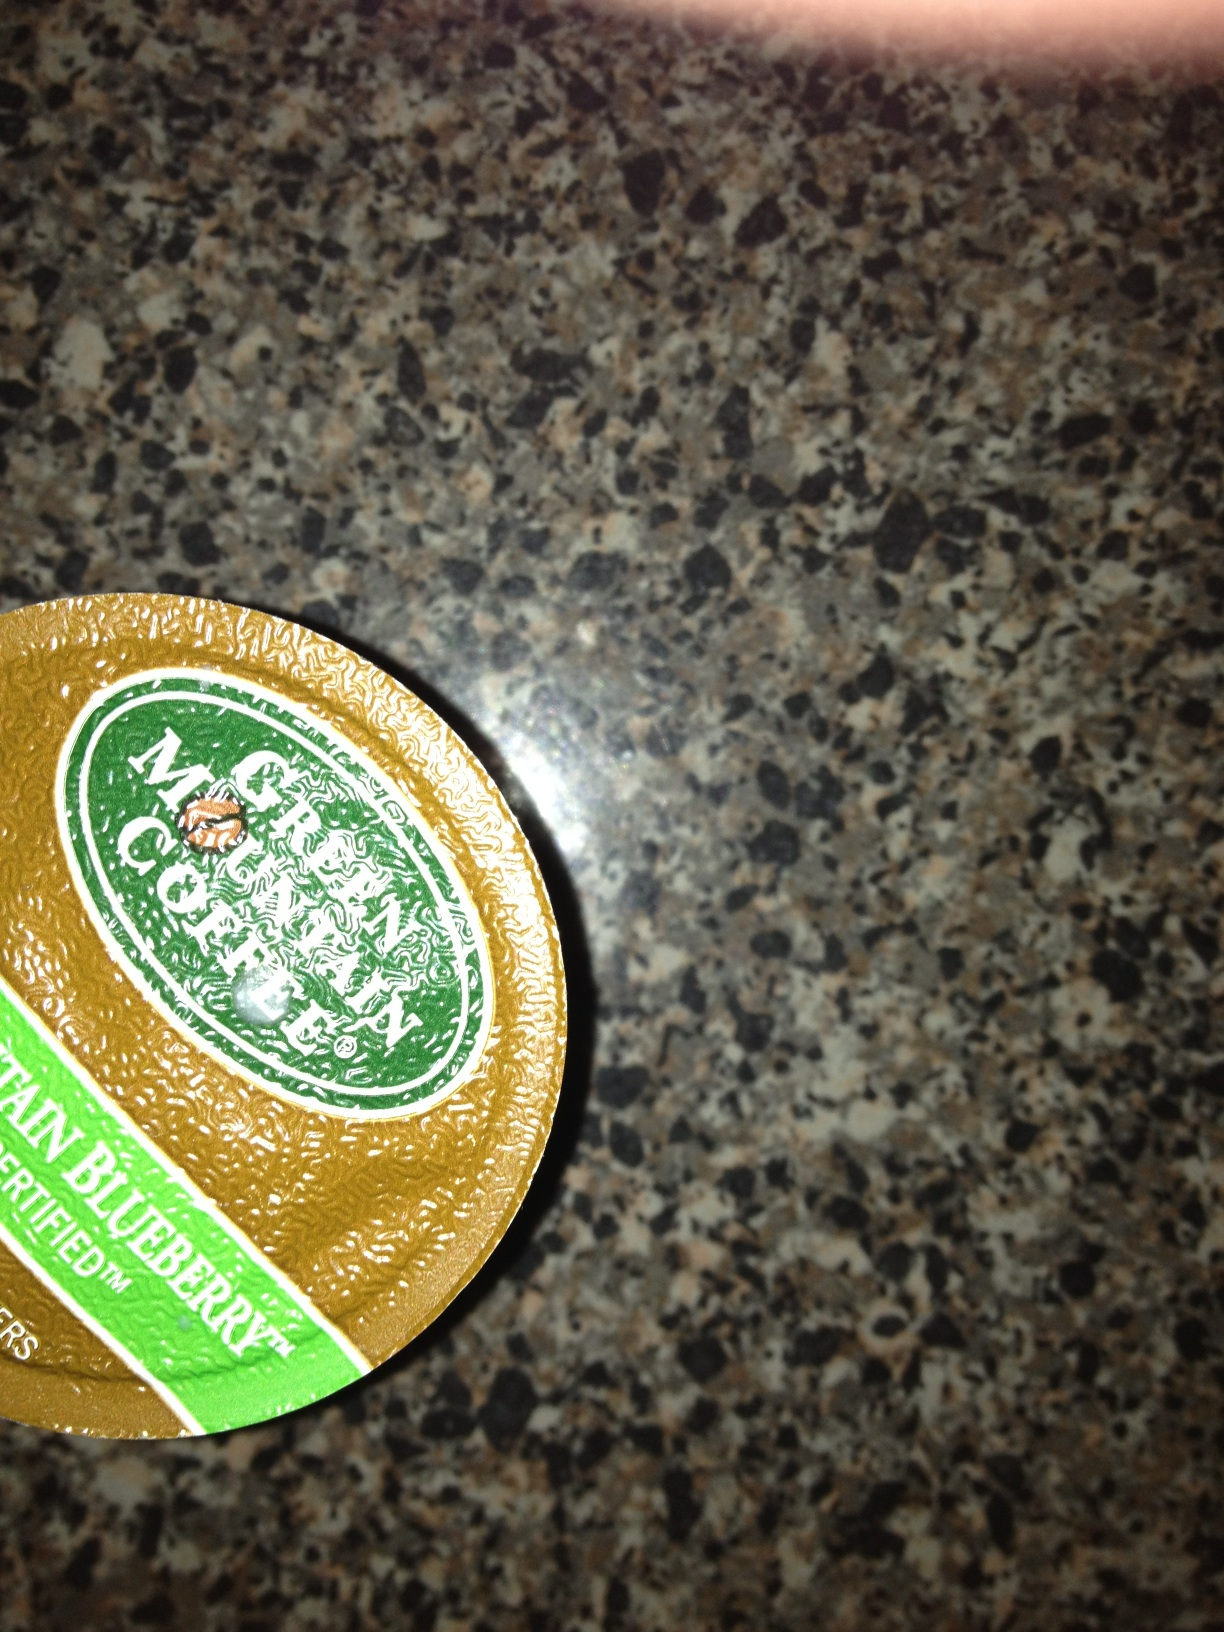What's a quick and tasty breakfast that pairs well with Mountain Blueberry coffee? A quick and tasty breakfast that pairs wonderfully with Mountain Blueberry coffee is a blueberry muffin with a side of Greek yogurt. The muffin complements the fruity notes of the coffee, while the Greek yogurt adds a creamy texture and a nutritional boost, making for a balanced and delicious breakfast routine. 